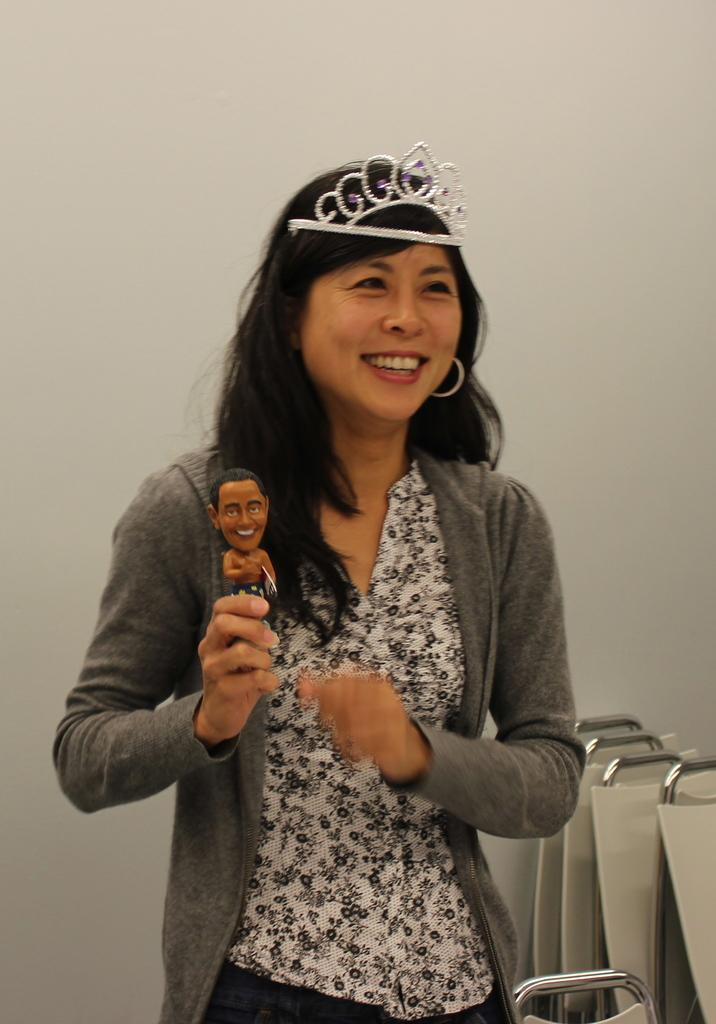What is the main subject of the image? There is a lady person in the image. Can you describe the lady person's clothing? The lady person is wearing a white top and an ash-colored cardigan. What is the lady person holding in her hands? The lady person is holding an animated toy in her hands. How many holes can be seen in the lady person's top in the image? There is no mention of any holes in the lady person's top in the image. What type of celery is the lady person holding in her hands? The lady person is not holding any celery in her hands; she is holding an animated toy. 